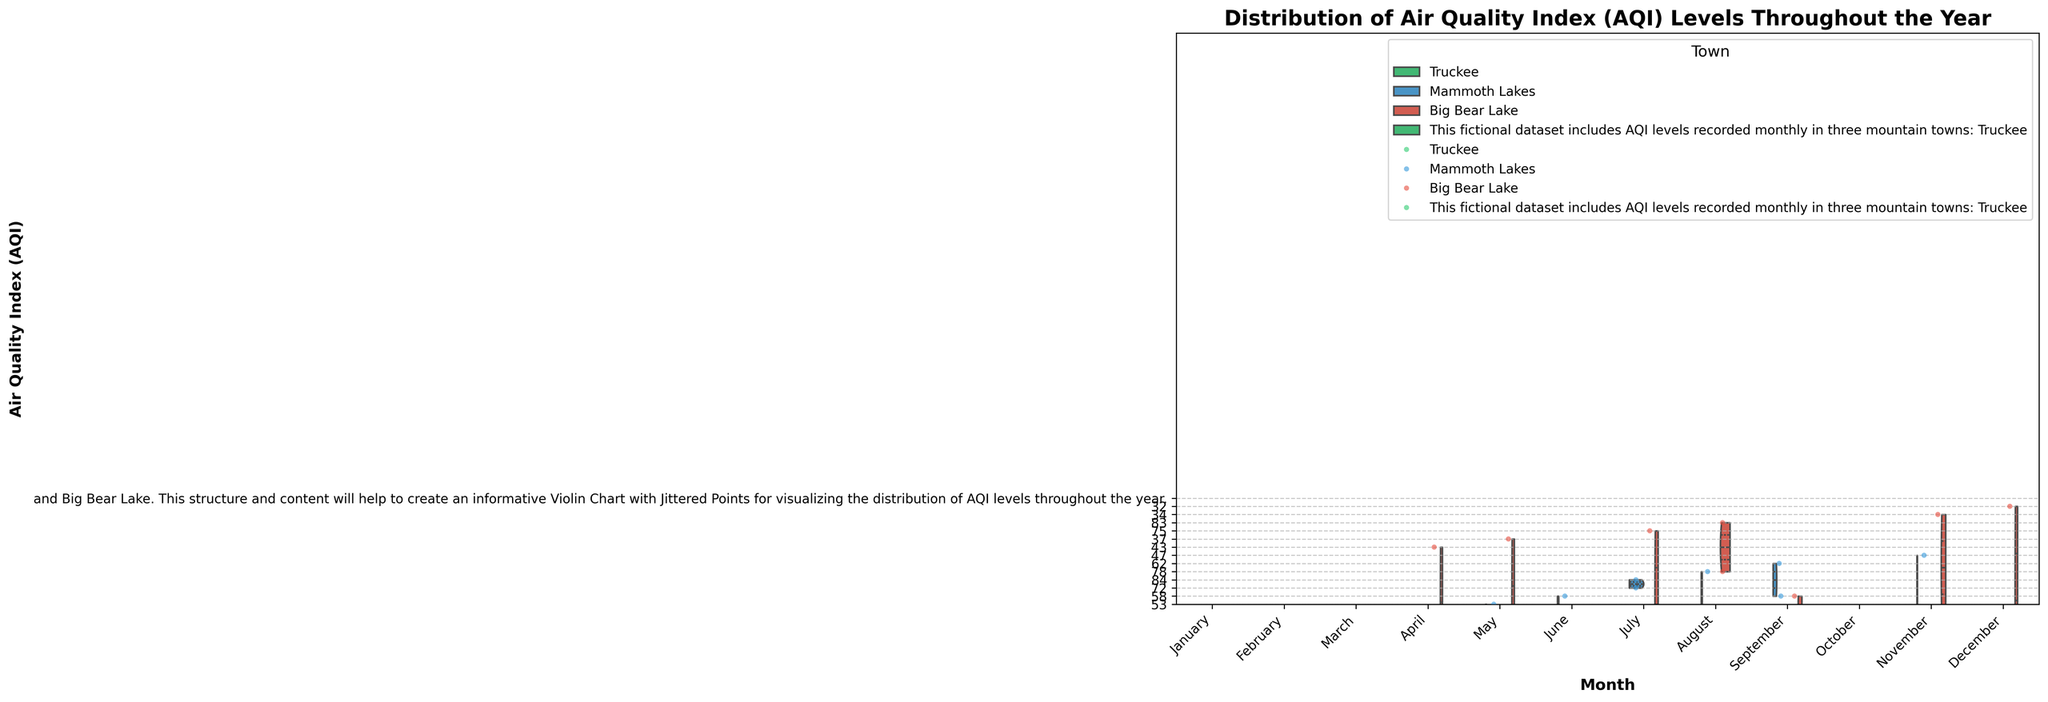Which town has the highest peak AQI in August? The violin plot shows the distribution of AQI levels for each town across different months. Look for the highest point on the violin plots for August among the three towns. The peak AQI for August is the highest for Truckee.
Answer: Truckee What is the title of the figure? The title of the figure is presented at the top of the plot. It reads "Distribution of Air Quality Index (AQI) Levels Throughout the Year".
Answer: Distribution of Air Quality Index (AQI) Levels Throughout the Year On which months do Truckee and Big Bear Lake show a significant increase in AQI levels? The significant increase in AQI levels is visible in the range of higher values in the violin plots. For Truckee, the peak happens in July and August, whereas for Big Bear Lake, significant increases occur in July and August.
Answer: July and August What is the maximum AQI range observed for Mammoth Lakes in June? The maximum AQI range corresponds to the span of the violin plot for Mammoth Lakes in June. This range extends from approximately 58 to 70.
Answer: 58 to 70 Which town has the lowest median AQI in February? The median, given by the white dot inside the violin plots, shows where the center point of the data lies. In February, Big Bear Lake's median is lower than those of the other towns.
Answer: Big Bear Lake How do the AQI values for Mammoth Lakes in October compare to those in November? For Mammoth Lakes, compare the height of the violin plots in October and November. The values in October and November are roughly similar with a slight decrease in November.
Answer: Roughly similar During which month does the AQI distribution for Truckee show the widest spread? The spread is visible from the width of the violin plot. For Truckee, the widest spread of AQI values occurs in August.
Answer: August How does the AQI in Big Bear Lake during December compare to January? Observe the position and spread of the AQI values in the violin plot for Big Bear Lake in December and January. December has a slightly higher AQI range compared to January.
Answer: Slightly higher in December What does the split hue in the violin plots indicate? The split hue in each violin plot indicates the different towns being compared in the months. This split shows how each town's AQI compares within the same month, with different halves representing different towns.
Answer: Comparison of towns What is the trend of AQI levels in Truckee from January to December? Follow the trend of the median line (white point inside the violin) for Truckee from January to December. The AQI levels generally increase from January, peaking in July and August, then decrease towards December.
Answer: Increase, peak in July and August, then decrease 